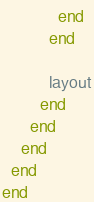Convert code to text. <code><loc_0><loc_0><loc_500><loc_500><_Ruby_>            end
          end

          layout
        end
      end
    end
  end
end
</code> 